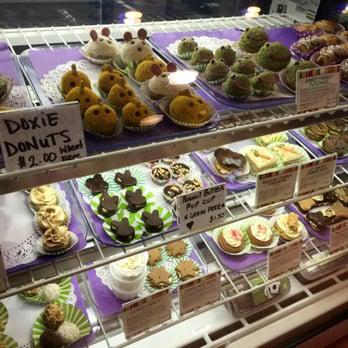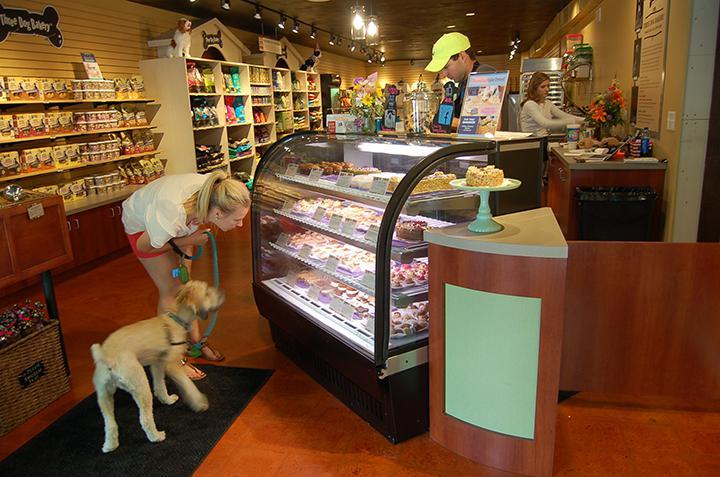The first image is the image on the left, the second image is the image on the right. Evaluate the accuracy of this statement regarding the images: "A white and black dog is standing near a glass case in one  of the images.". Is it true? Answer yes or no. No. 